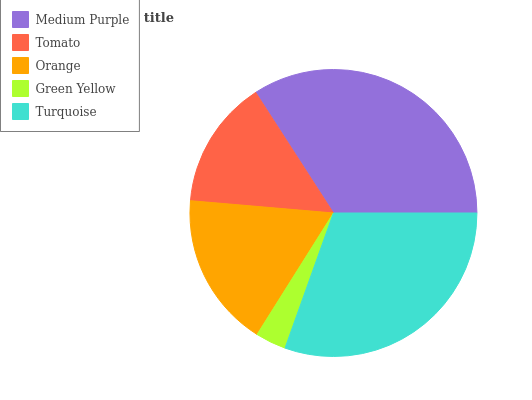Is Green Yellow the minimum?
Answer yes or no. Yes. Is Medium Purple the maximum?
Answer yes or no. Yes. Is Tomato the minimum?
Answer yes or no. No. Is Tomato the maximum?
Answer yes or no. No. Is Medium Purple greater than Tomato?
Answer yes or no. Yes. Is Tomato less than Medium Purple?
Answer yes or no. Yes. Is Tomato greater than Medium Purple?
Answer yes or no. No. Is Medium Purple less than Tomato?
Answer yes or no. No. Is Orange the high median?
Answer yes or no. Yes. Is Orange the low median?
Answer yes or no. Yes. Is Medium Purple the high median?
Answer yes or no. No. Is Turquoise the low median?
Answer yes or no. No. 